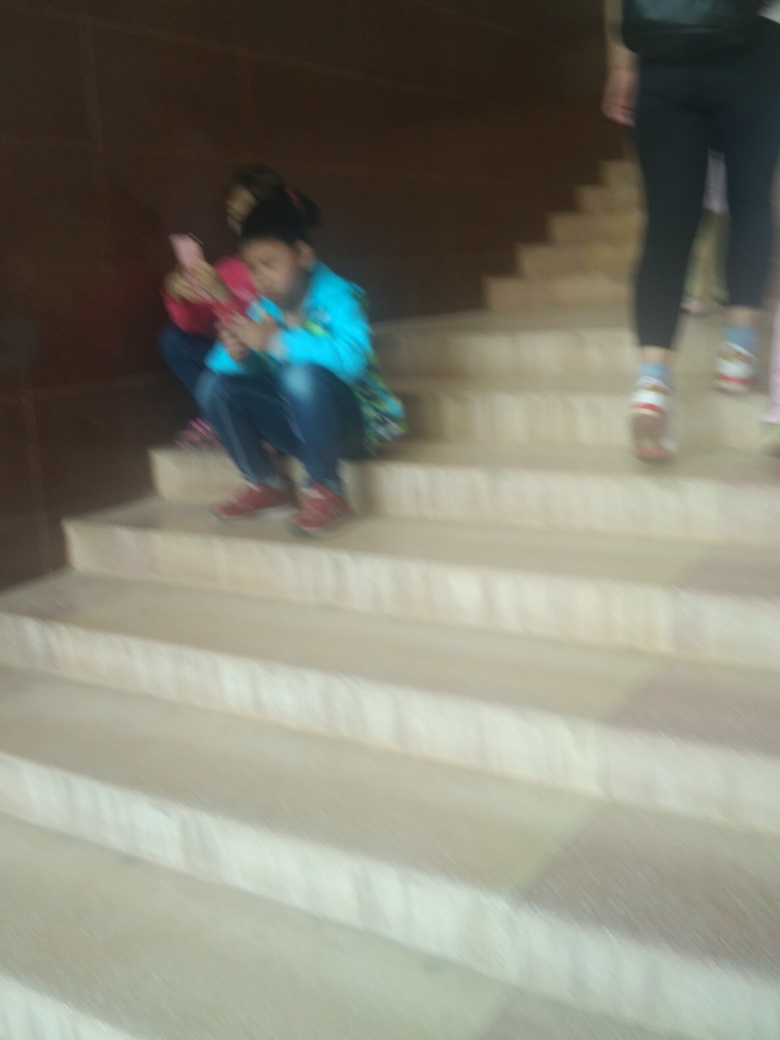How would you describe the facial expressions in the image?
A. Expressive
B. Not clear
C. Emotional While the image is blurry and specific details are not clear, the context suggests some emotion. Subjects appear to be engaged in an activity which might suggest emotion, potentially aligning with option C: Emotional. 